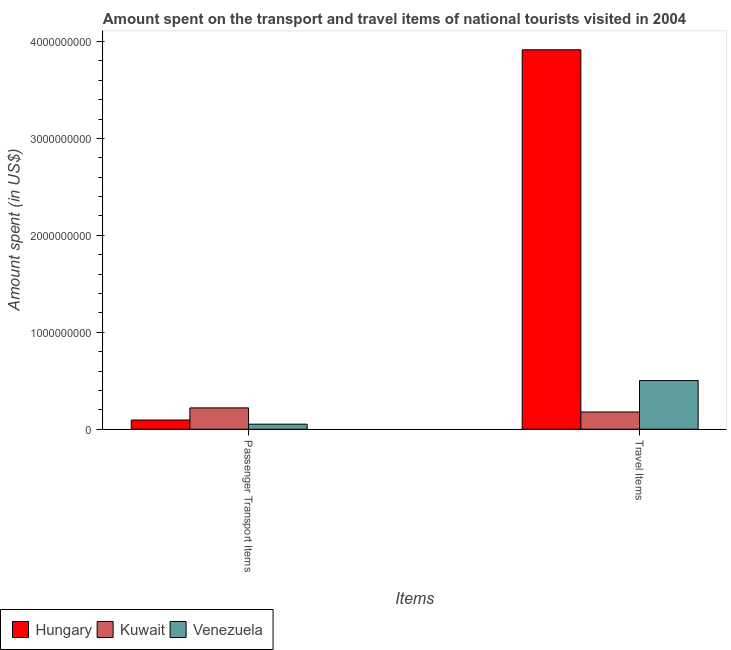How many groups of bars are there?
Provide a short and direct response. 2. Are the number of bars per tick equal to the number of legend labels?
Make the answer very short. Yes. Are the number of bars on each tick of the X-axis equal?
Give a very brief answer. Yes. What is the label of the 1st group of bars from the left?
Offer a very short reply. Passenger Transport Items. What is the amount spent in travel items in Venezuela?
Your response must be concise. 5.02e+08. Across all countries, what is the maximum amount spent on passenger transport items?
Your response must be concise. 2.20e+08. Across all countries, what is the minimum amount spent on passenger transport items?
Make the answer very short. 5.20e+07. In which country was the amount spent in travel items maximum?
Your answer should be compact. Hungary. In which country was the amount spent in travel items minimum?
Offer a terse response. Kuwait. What is the total amount spent on passenger transport items in the graph?
Offer a terse response. 3.67e+08. What is the difference between the amount spent on passenger transport items in Venezuela and that in Hungary?
Your response must be concise. -4.30e+07. What is the difference between the amount spent in travel items in Kuwait and the amount spent on passenger transport items in Hungary?
Ensure brevity in your answer.  8.30e+07. What is the average amount spent on passenger transport items per country?
Provide a short and direct response. 1.22e+08. What is the difference between the amount spent in travel items and amount spent on passenger transport items in Kuwait?
Keep it short and to the point. -4.20e+07. In how many countries, is the amount spent in travel items greater than 200000000 US$?
Offer a very short reply. 2. What is the ratio of the amount spent on passenger transport items in Kuwait to that in Venezuela?
Offer a terse response. 4.23. What does the 2nd bar from the left in Travel Items represents?
Offer a terse response. Kuwait. What does the 1st bar from the right in Travel Items represents?
Keep it short and to the point. Venezuela. Are all the bars in the graph horizontal?
Provide a succinct answer. No. How many countries are there in the graph?
Provide a succinct answer. 3. Does the graph contain grids?
Give a very brief answer. No. Where does the legend appear in the graph?
Offer a very short reply. Bottom left. How are the legend labels stacked?
Give a very brief answer. Horizontal. What is the title of the graph?
Give a very brief answer. Amount spent on the transport and travel items of national tourists visited in 2004. What is the label or title of the X-axis?
Your answer should be very brief. Items. What is the label or title of the Y-axis?
Provide a short and direct response. Amount spent (in US$). What is the Amount spent (in US$) in Hungary in Passenger Transport Items?
Give a very brief answer. 9.50e+07. What is the Amount spent (in US$) of Kuwait in Passenger Transport Items?
Offer a terse response. 2.20e+08. What is the Amount spent (in US$) in Venezuela in Passenger Transport Items?
Offer a terse response. 5.20e+07. What is the Amount spent (in US$) in Hungary in Travel Items?
Offer a terse response. 3.91e+09. What is the Amount spent (in US$) in Kuwait in Travel Items?
Offer a terse response. 1.78e+08. What is the Amount spent (in US$) of Venezuela in Travel Items?
Keep it short and to the point. 5.02e+08. Across all Items, what is the maximum Amount spent (in US$) of Hungary?
Ensure brevity in your answer.  3.91e+09. Across all Items, what is the maximum Amount spent (in US$) in Kuwait?
Your response must be concise. 2.20e+08. Across all Items, what is the maximum Amount spent (in US$) in Venezuela?
Your answer should be compact. 5.02e+08. Across all Items, what is the minimum Amount spent (in US$) in Hungary?
Provide a short and direct response. 9.50e+07. Across all Items, what is the minimum Amount spent (in US$) in Kuwait?
Give a very brief answer. 1.78e+08. Across all Items, what is the minimum Amount spent (in US$) in Venezuela?
Keep it short and to the point. 5.20e+07. What is the total Amount spent (in US$) in Hungary in the graph?
Provide a succinct answer. 4.01e+09. What is the total Amount spent (in US$) of Kuwait in the graph?
Your response must be concise. 3.98e+08. What is the total Amount spent (in US$) of Venezuela in the graph?
Ensure brevity in your answer.  5.54e+08. What is the difference between the Amount spent (in US$) in Hungary in Passenger Transport Items and that in Travel Items?
Ensure brevity in your answer.  -3.82e+09. What is the difference between the Amount spent (in US$) of Kuwait in Passenger Transport Items and that in Travel Items?
Your answer should be compact. 4.20e+07. What is the difference between the Amount spent (in US$) in Venezuela in Passenger Transport Items and that in Travel Items?
Offer a terse response. -4.50e+08. What is the difference between the Amount spent (in US$) in Hungary in Passenger Transport Items and the Amount spent (in US$) in Kuwait in Travel Items?
Provide a succinct answer. -8.30e+07. What is the difference between the Amount spent (in US$) of Hungary in Passenger Transport Items and the Amount spent (in US$) of Venezuela in Travel Items?
Keep it short and to the point. -4.07e+08. What is the difference between the Amount spent (in US$) of Kuwait in Passenger Transport Items and the Amount spent (in US$) of Venezuela in Travel Items?
Offer a very short reply. -2.82e+08. What is the average Amount spent (in US$) in Hungary per Items?
Your response must be concise. 2.00e+09. What is the average Amount spent (in US$) of Kuwait per Items?
Ensure brevity in your answer.  1.99e+08. What is the average Amount spent (in US$) in Venezuela per Items?
Your answer should be very brief. 2.77e+08. What is the difference between the Amount spent (in US$) of Hungary and Amount spent (in US$) of Kuwait in Passenger Transport Items?
Provide a succinct answer. -1.25e+08. What is the difference between the Amount spent (in US$) of Hungary and Amount spent (in US$) of Venezuela in Passenger Transport Items?
Provide a succinct answer. 4.30e+07. What is the difference between the Amount spent (in US$) in Kuwait and Amount spent (in US$) in Venezuela in Passenger Transport Items?
Your response must be concise. 1.68e+08. What is the difference between the Amount spent (in US$) in Hungary and Amount spent (in US$) in Kuwait in Travel Items?
Offer a terse response. 3.74e+09. What is the difference between the Amount spent (in US$) in Hungary and Amount spent (in US$) in Venezuela in Travel Items?
Provide a succinct answer. 3.41e+09. What is the difference between the Amount spent (in US$) of Kuwait and Amount spent (in US$) of Venezuela in Travel Items?
Your answer should be very brief. -3.24e+08. What is the ratio of the Amount spent (in US$) in Hungary in Passenger Transport Items to that in Travel Items?
Provide a succinct answer. 0.02. What is the ratio of the Amount spent (in US$) in Kuwait in Passenger Transport Items to that in Travel Items?
Give a very brief answer. 1.24. What is the ratio of the Amount spent (in US$) in Venezuela in Passenger Transport Items to that in Travel Items?
Offer a very short reply. 0.1. What is the difference between the highest and the second highest Amount spent (in US$) in Hungary?
Offer a very short reply. 3.82e+09. What is the difference between the highest and the second highest Amount spent (in US$) in Kuwait?
Offer a very short reply. 4.20e+07. What is the difference between the highest and the second highest Amount spent (in US$) in Venezuela?
Keep it short and to the point. 4.50e+08. What is the difference between the highest and the lowest Amount spent (in US$) in Hungary?
Offer a very short reply. 3.82e+09. What is the difference between the highest and the lowest Amount spent (in US$) in Kuwait?
Provide a short and direct response. 4.20e+07. What is the difference between the highest and the lowest Amount spent (in US$) of Venezuela?
Provide a short and direct response. 4.50e+08. 